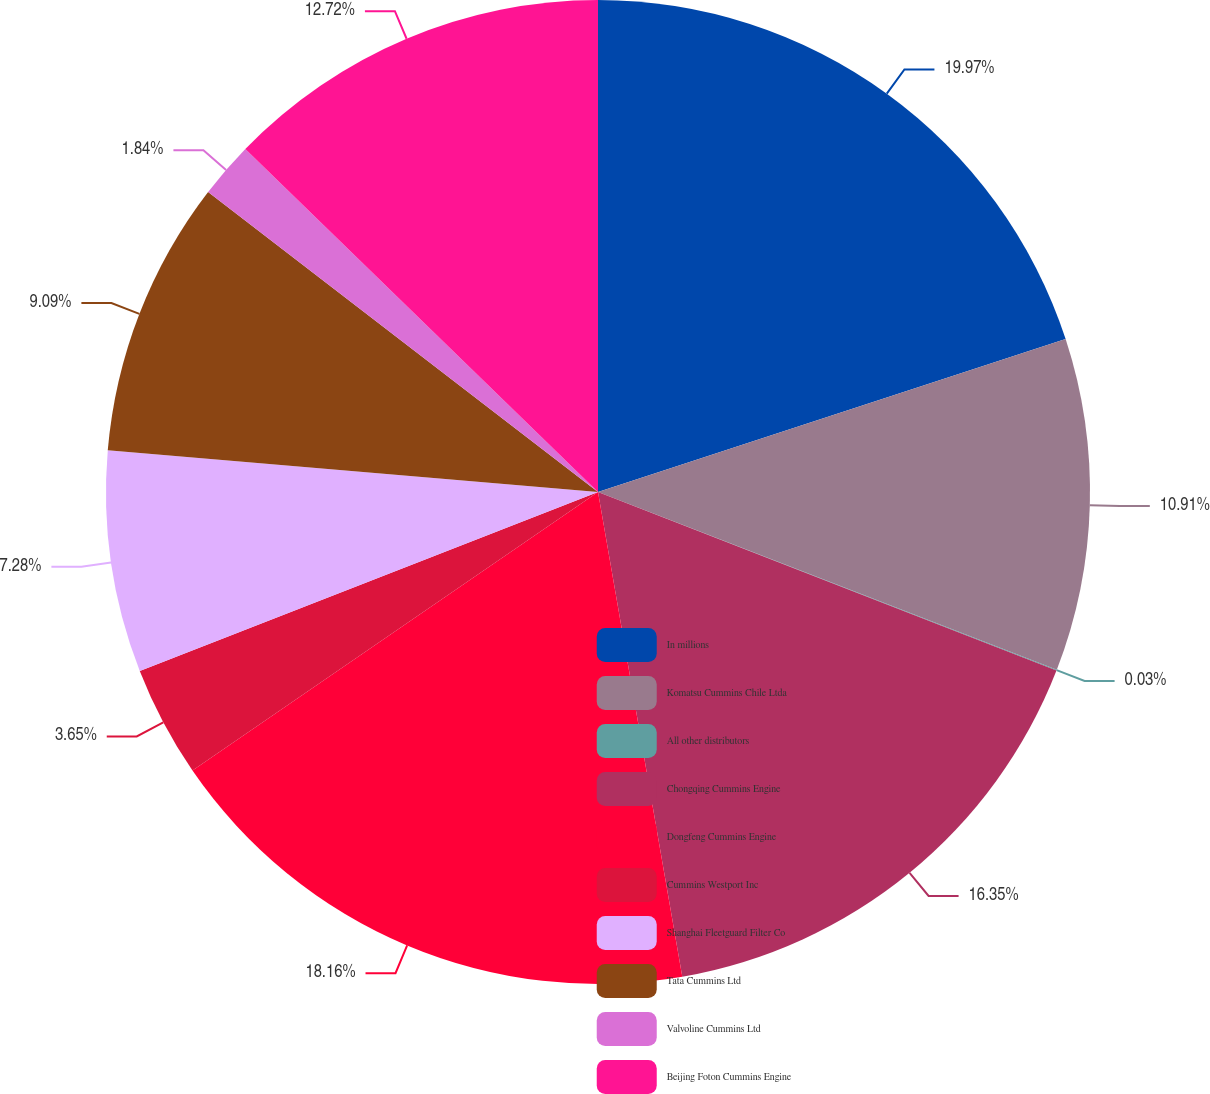<chart> <loc_0><loc_0><loc_500><loc_500><pie_chart><fcel>In millions<fcel>Komatsu Cummins Chile Ltda<fcel>All other distributors<fcel>Chongqing Cummins Engine<fcel>Dongfeng Cummins Engine<fcel>Cummins Westport Inc<fcel>Shanghai Fleetguard Filter Co<fcel>Tata Cummins Ltd<fcel>Valvoline Cummins Ltd<fcel>Beijing Foton Cummins Engine<nl><fcel>19.97%<fcel>10.91%<fcel>0.03%<fcel>16.35%<fcel>18.16%<fcel>3.65%<fcel>7.28%<fcel>9.09%<fcel>1.84%<fcel>12.72%<nl></chart> 